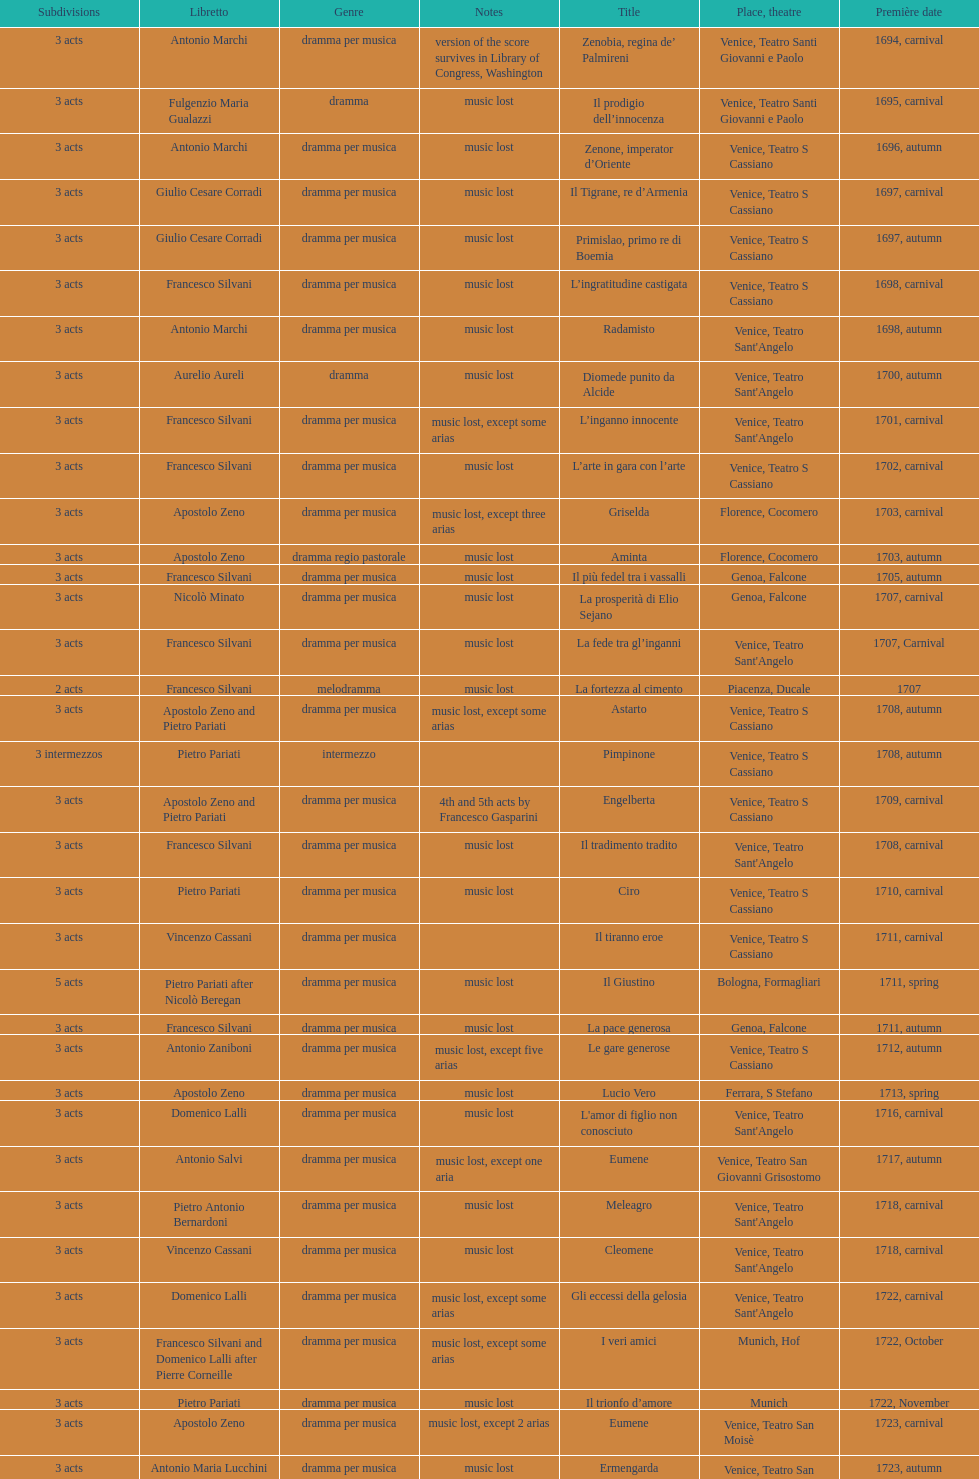How many operas on this list has at least 3 acts? 51. 